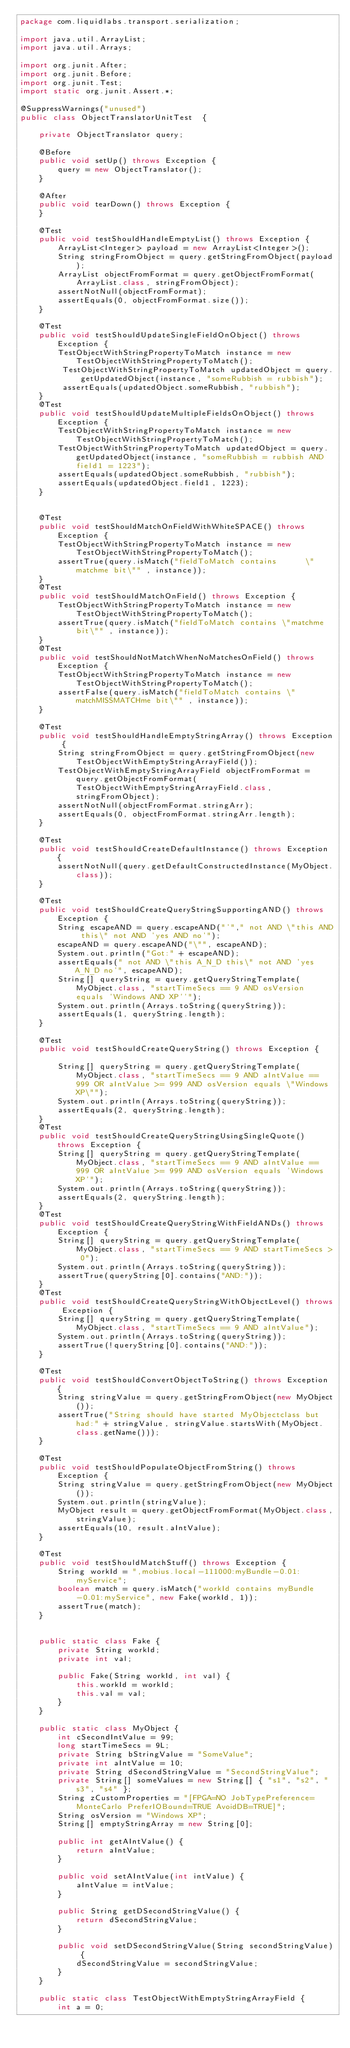Convert code to text. <code><loc_0><loc_0><loc_500><loc_500><_Java_>package com.liquidlabs.transport.serialization;

import java.util.ArrayList;
import java.util.Arrays;

import org.junit.After;
import org.junit.Before;
import org.junit.Test;
import static org.junit.Assert.*;

@SuppressWarnings("unused")
public class ObjectTranslatorUnitTest  {

	private ObjectTranslator query;

	@Before
	public void setUp() throws Exception {
		query = new ObjectTranslator();
	}

	@After
	public void tearDown() throws Exception {
	}

	@Test
	public void testShouldHandleEmptyList() throws Exception {
		ArrayList<Integer> payload = new ArrayList<Integer>();
		String stringFromObject = query.getStringFromObject(payload);
		ArrayList objectFromFormat = query.getObjectFromFormat(ArrayList.class, stringFromObject);
		assertNotNull(objectFromFormat);
		assertEquals(0, objectFromFormat.size());
	}
	
	@Test
	public void testShouldUpdateSingleFieldOnObject() throws Exception {
		TestObjectWithStringPropertyToMatch instance = new TestObjectWithStringPropertyToMatch();
		 TestObjectWithStringPropertyToMatch updatedObject = query.getUpdatedObject(instance, "someRubbish = rubbish");
		 assertEquals(updatedObject.someRubbish, "rubbish");
	}
	@Test
	public void testShouldUpdateMultipleFieldsOnObject() throws Exception {
		TestObjectWithStringPropertyToMatch instance = new TestObjectWithStringPropertyToMatch();
		TestObjectWithStringPropertyToMatch updatedObject = query.getUpdatedObject(instance, "someRubbish = rubbish AND field1 = 1223");
		assertEquals(updatedObject.someRubbish, "rubbish");
		assertEquals(updatedObject.field1, 1223);
	}
	
	
	@Test
	public void testShouldMatchOnFieldWithWhiteSPACE() throws Exception {
		TestObjectWithStringPropertyToMatch instance = new TestObjectWithStringPropertyToMatch();
		assertTrue(query.isMatch("fieldToMatch contains      \"matchme bit\"" , instance));
	}
	@Test
	public void testShouldMatchOnField() throws Exception {
		TestObjectWithStringPropertyToMatch instance = new TestObjectWithStringPropertyToMatch();
		assertTrue(query.isMatch("fieldToMatch contains \"matchme bit\"" , instance));
	}
	@Test
	public void testShouldNotMatchWhenNoMatchesOnField() throws Exception {
		TestObjectWithStringPropertyToMatch instance = new TestObjectWithStringPropertyToMatch();
		assertFalse(query.isMatch("fieldToMatch contains \"matchMISSMATCHme bit\"" , instance));
	}

	@Test
	public void testShouldHandleEmptyStringArray() throws Exception {
		String stringFromObject = query.getStringFromObject(new TestObjectWithEmptyStringArrayField());
		TestObjectWithEmptyStringArrayField objectFromFormat = query.getObjectFromFormat(TestObjectWithEmptyStringArrayField.class, stringFromObject);
		assertNotNull(objectFromFormat.stringArr);
		assertEquals(0, objectFromFormat.stringArr.length);
	}
	
	@Test
	public void testShouldCreateDefaultInstance() throws Exception {
		assertNotNull(query.getDefaultConstructedInstance(MyObject.class));
	}

	@Test
	public void testShouldCreateQueryStringSupportingAND() throws Exception {
		String escapeAND = query.escapeAND("'"," not AND \"this AND this\" not AND 'yes AND no'");
		escapeAND = query.escapeAND("\"", escapeAND);
		System.out.println("Got:" + escapeAND);
		assertEquals(" not AND \"this A_N_D this\" not AND 'yes A_N_D no'", escapeAND);
		String[] queryString = query.getQueryStringTemplate(MyObject.class, "startTimeSecs == 9 AND osVersion equals 'Windows AND XP''");
		System.out.println(Arrays.toString(queryString));
		assertEquals(1, queryString.length);
	}
	
	@Test
	public void testShouldCreateQueryString() throws Exception {		
		String[] queryString = query.getQueryStringTemplate(MyObject.class, "startTimeSecs == 9 AND aIntValue == 999 OR aIntValue >= 999 AND osVersion equals \"Windows XP\"");
		System.out.println(Arrays.toString(queryString));
		assertEquals(2, queryString.length);
	}
	@Test
	public void testShouldCreateQueryStringUsingSingleQuote() throws Exception {		
		String[] queryString = query.getQueryStringTemplate(MyObject.class, "startTimeSecs == 9 AND aIntValue == 999 OR aIntValue >= 999 AND osVersion equals 'Windows XP'");
		System.out.println(Arrays.toString(queryString));
		assertEquals(2, queryString.length);
	}
	@Test
	public void testShouldCreateQueryStringWithFieldANDs() throws Exception {		
		String[] queryString = query.getQueryStringTemplate(MyObject.class, "startTimeSecs == 9 AND startTimeSecs > 0");
		System.out.println(Arrays.toString(queryString));
		assertTrue(queryString[0].contains("AND:"));
	}
	@Test
	public void testShouldCreateQueryStringWithObjectLevel() throws Exception {		
		String[] queryString = query.getQueryStringTemplate(MyObject.class, "startTimeSecs == 9 AND aIntValue");
		System.out.println(Arrays.toString(queryString));
		assertTrue(!queryString[0].contains("AND:"));
	}

	@Test
	public void testShouldConvertObjectToString() throws Exception {
		String stringValue = query.getStringFromObject(new MyObject());
		assertTrue("String should have started MyObjectclass but had:" + stringValue, stringValue.startsWith(MyObject.class.getName()));
	}

	@Test
	public void testShouldPopulateObjectFromString() throws Exception {
		String stringValue = query.getStringFromObject(new MyObject());
		System.out.println(stringValue);
		MyObject result = query.getObjectFromFormat(MyObject.class,stringValue);
		assertEquals(10, result.aIntValue);
	}
	
	@Test
	public void testShouldMatchStuff() throws Exception {
		String workId = ",mobius.local-111000:myBundle-0.01:myService";
		boolean match = query.isMatch("workId contains myBundle-0.01:myService", new Fake(workId, 1));
		assertTrue(match);
	}
	
	
	public static class Fake {
		private String workId;
		private int val;

		public Fake(String workId, int val) {
			this.workId = workId;
			this.val = val;
		}
	}
	
	public static class MyObject {
		int cSecondIntValue = 99;
		long startTimeSecs = 9L;
		private String bStringValue = "SomeValue";
		private int aIntValue = 10;
		private String dSecondStringValue = "SecondStringValue";
		private String[] someValues = new String[] { "s1", "s2", "s3", "s4" };
		String zCustomProperties = "[FPGA=NO JobTypePreference=MonteCarlo PreferIOBound=TRUE AvoidDB=TRUE]";
		String osVersion = "Windows XP";
		String[] emptyStringArray = new String[0];

		public int getAIntValue() {
			return aIntValue;
		}

		public void setAIntValue(int intValue) {
			aIntValue = intValue;
		}

		public String getDSecondStringValue() {
			return dSecondStringValue;
		}

		public void setDSecondStringValue(String secondStringValue) {
			dSecondStringValue = secondStringValue;
		}
	}
	
	public static class TestObjectWithEmptyStringArrayField {
		int a = 0;</code> 